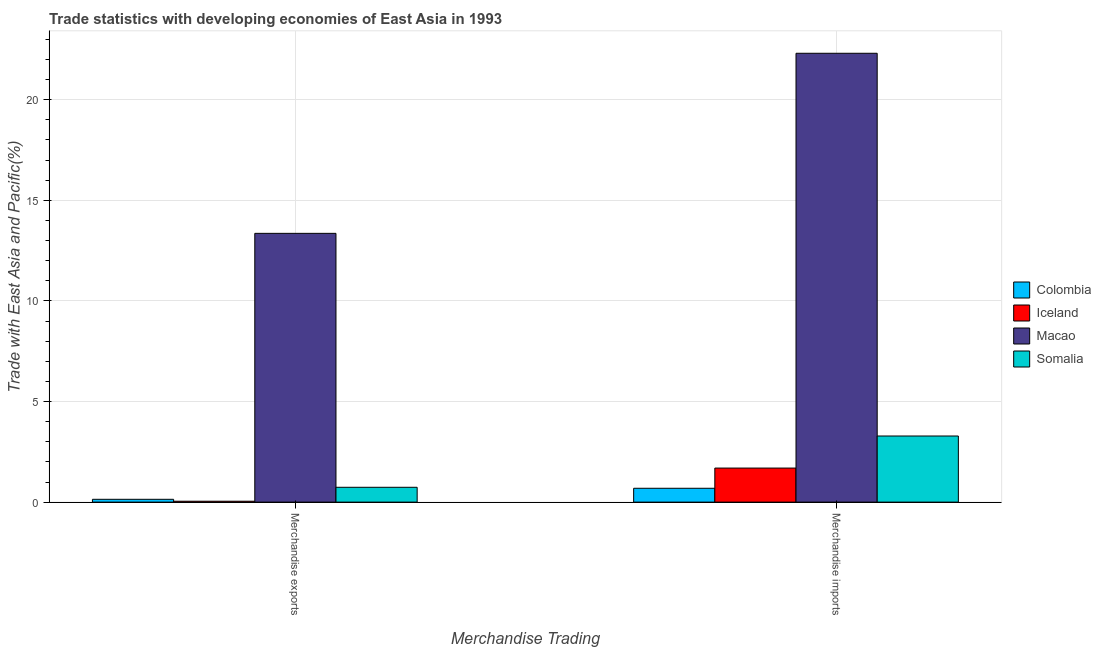Are the number of bars on each tick of the X-axis equal?
Provide a succinct answer. Yes. How many bars are there on the 2nd tick from the left?
Offer a very short reply. 4. What is the label of the 1st group of bars from the left?
Give a very brief answer. Merchandise exports. What is the merchandise imports in Somalia?
Offer a terse response. 3.29. Across all countries, what is the maximum merchandise imports?
Ensure brevity in your answer.  22.31. Across all countries, what is the minimum merchandise exports?
Your response must be concise. 0.04. In which country was the merchandise exports maximum?
Make the answer very short. Macao. What is the total merchandise imports in the graph?
Offer a terse response. 27.97. What is the difference between the merchandise imports in Iceland and that in Somalia?
Your answer should be very brief. -1.59. What is the difference between the merchandise exports in Somalia and the merchandise imports in Iceland?
Provide a succinct answer. -0.96. What is the average merchandise exports per country?
Provide a succinct answer. 3.57. What is the difference between the merchandise exports and merchandise imports in Colombia?
Provide a succinct answer. -0.55. What is the ratio of the merchandise exports in Iceland to that in Macao?
Ensure brevity in your answer.  0. Is the merchandise exports in Iceland less than that in Colombia?
Your answer should be compact. Yes. What does the 3rd bar from the left in Merchandise exports represents?
Give a very brief answer. Macao. What does the 1st bar from the right in Merchandise imports represents?
Your answer should be compact. Somalia. How many countries are there in the graph?
Provide a short and direct response. 4. Are the values on the major ticks of Y-axis written in scientific E-notation?
Keep it short and to the point. No. Does the graph contain any zero values?
Provide a short and direct response. No. Does the graph contain grids?
Your response must be concise. Yes. How many legend labels are there?
Provide a succinct answer. 4. How are the legend labels stacked?
Offer a terse response. Vertical. What is the title of the graph?
Give a very brief answer. Trade statistics with developing economies of East Asia in 1993. What is the label or title of the X-axis?
Make the answer very short. Merchandise Trading. What is the label or title of the Y-axis?
Provide a succinct answer. Trade with East Asia and Pacific(%). What is the Trade with East Asia and Pacific(%) in Colombia in Merchandise exports?
Your response must be concise. 0.14. What is the Trade with East Asia and Pacific(%) of Iceland in Merchandise exports?
Offer a very short reply. 0.04. What is the Trade with East Asia and Pacific(%) of Macao in Merchandise exports?
Give a very brief answer. 13.36. What is the Trade with East Asia and Pacific(%) in Somalia in Merchandise exports?
Provide a succinct answer. 0.74. What is the Trade with East Asia and Pacific(%) in Colombia in Merchandise imports?
Give a very brief answer. 0.69. What is the Trade with East Asia and Pacific(%) of Iceland in Merchandise imports?
Make the answer very short. 1.69. What is the Trade with East Asia and Pacific(%) in Macao in Merchandise imports?
Keep it short and to the point. 22.31. What is the Trade with East Asia and Pacific(%) of Somalia in Merchandise imports?
Give a very brief answer. 3.29. Across all Merchandise Trading, what is the maximum Trade with East Asia and Pacific(%) in Colombia?
Offer a terse response. 0.69. Across all Merchandise Trading, what is the maximum Trade with East Asia and Pacific(%) in Iceland?
Give a very brief answer. 1.69. Across all Merchandise Trading, what is the maximum Trade with East Asia and Pacific(%) of Macao?
Your answer should be compact. 22.31. Across all Merchandise Trading, what is the maximum Trade with East Asia and Pacific(%) in Somalia?
Ensure brevity in your answer.  3.29. Across all Merchandise Trading, what is the minimum Trade with East Asia and Pacific(%) in Colombia?
Offer a terse response. 0.14. Across all Merchandise Trading, what is the minimum Trade with East Asia and Pacific(%) in Iceland?
Offer a terse response. 0.04. Across all Merchandise Trading, what is the minimum Trade with East Asia and Pacific(%) in Macao?
Give a very brief answer. 13.36. Across all Merchandise Trading, what is the minimum Trade with East Asia and Pacific(%) in Somalia?
Keep it short and to the point. 0.74. What is the total Trade with East Asia and Pacific(%) in Colombia in the graph?
Offer a terse response. 0.83. What is the total Trade with East Asia and Pacific(%) of Iceland in the graph?
Offer a terse response. 1.74. What is the total Trade with East Asia and Pacific(%) in Macao in the graph?
Offer a terse response. 35.66. What is the total Trade with East Asia and Pacific(%) in Somalia in the graph?
Ensure brevity in your answer.  4.02. What is the difference between the Trade with East Asia and Pacific(%) in Colombia in Merchandise exports and that in Merchandise imports?
Your answer should be compact. -0.55. What is the difference between the Trade with East Asia and Pacific(%) of Iceland in Merchandise exports and that in Merchandise imports?
Provide a short and direct response. -1.65. What is the difference between the Trade with East Asia and Pacific(%) of Macao in Merchandise exports and that in Merchandise imports?
Make the answer very short. -8.95. What is the difference between the Trade with East Asia and Pacific(%) in Somalia in Merchandise exports and that in Merchandise imports?
Ensure brevity in your answer.  -2.55. What is the difference between the Trade with East Asia and Pacific(%) in Colombia in Merchandise exports and the Trade with East Asia and Pacific(%) in Iceland in Merchandise imports?
Your answer should be compact. -1.55. What is the difference between the Trade with East Asia and Pacific(%) in Colombia in Merchandise exports and the Trade with East Asia and Pacific(%) in Macao in Merchandise imports?
Give a very brief answer. -22.17. What is the difference between the Trade with East Asia and Pacific(%) in Colombia in Merchandise exports and the Trade with East Asia and Pacific(%) in Somalia in Merchandise imports?
Your answer should be compact. -3.15. What is the difference between the Trade with East Asia and Pacific(%) in Iceland in Merchandise exports and the Trade with East Asia and Pacific(%) in Macao in Merchandise imports?
Give a very brief answer. -22.26. What is the difference between the Trade with East Asia and Pacific(%) in Iceland in Merchandise exports and the Trade with East Asia and Pacific(%) in Somalia in Merchandise imports?
Your response must be concise. -3.24. What is the difference between the Trade with East Asia and Pacific(%) in Macao in Merchandise exports and the Trade with East Asia and Pacific(%) in Somalia in Merchandise imports?
Ensure brevity in your answer.  10.07. What is the average Trade with East Asia and Pacific(%) in Colombia per Merchandise Trading?
Provide a short and direct response. 0.41. What is the average Trade with East Asia and Pacific(%) in Iceland per Merchandise Trading?
Give a very brief answer. 0.87. What is the average Trade with East Asia and Pacific(%) in Macao per Merchandise Trading?
Ensure brevity in your answer.  17.83. What is the average Trade with East Asia and Pacific(%) in Somalia per Merchandise Trading?
Provide a short and direct response. 2.01. What is the difference between the Trade with East Asia and Pacific(%) in Colombia and Trade with East Asia and Pacific(%) in Iceland in Merchandise exports?
Offer a very short reply. 0.1. What is the difference between the Trade with East Asia and Pacific(%) of Colombia and Trade with East Asia and Pacific(%) of Macao in Merchandise exports?
Offer a terse response. -13.22. What is the difference between the Trade with East Asia and Pacific(%) of Colombia and Trade with East Asia and Pacific(%) of Somalia in Merchandise exports?
Provide a short and direct response. -0.6. What is the difference between the Trade with East Asia and Pacific(%) in Iceland and Trade with East Asia and Pacific(%) in Macao in Merchandise exports?
Offer a terse response. -13.31. What is the difference between the Trade with East Asia and Pacific(%) of Iceland and Trade with East Asia and Pacific(%) of Somalia in Merchandise exports?
Give a very brief answer. -0.69. What is the difference between the Trade with East Asia and Pacific(%) in Macao and Trade with East Asia and Pacific(%) in Somalia in Merchandise exports?
Keep it short and to the point. 12.62. What is the difference between the Trade with East Asia and Pacific(%) of Colombia and Trade with East Asia and Pacific(%) of Iceland in Merchandise imports?
Provide a short and direct response. -1. What is the difference between the Trade with East Asia and Pacific(%) of Colombia and Trade with East Asia and Pacific(%) of Macao in Merchandise imports?
Offer a terse response. -21.62. What is the difference between the Trade with East Asia and Pacific(%) of Colombia and Trade with East Asia and Pacific(%) of Somalia in Merchandise imports?
Give a very brief answer. -2.6. What is the difference between the Trade with East Asia and Pacific(%) of Iceland and Trade with East Asia and Pacific(%) of Macao in Merchandise imports?
Ensure brevity in your answer.  -20.61. What is the difference between the Trade with East Asia and Pacific(%) of Iceland and Trade with East Asia and Pacific(%) of Somalia in Merchandise imports?
Your answer should be very brief. -1.59. What is the difference between the Trade with East Asia and Pacific(%) in Macao and Trade with East Asia and Pacific(%) in Somalia in Merchandise imports?
Your answer should be compact. 19.02. What is the ratio of the Trade with East Asia and Pacific(%) in Colombia in Merchandise exports to that in Merchandise imports?
Provide a succinct answer. 0.2. What is the ratio of the Trade with East Asia and Pacific(%) in Iceland in Merchandise exports to that in Merchandise imports?
Offer a terse response. 0.03. What is the ratio of the Trade with East Asia and Pacific(%) of Macao in Merchandise exports to that in Merchandise imports?
Keep it short and to the point. 0.6. What is the ratio of the Trade with East Asia and Pacific(%) of Somalia in Merchandise exports to that in Merchandise imports?
Your response must be concise. 0.22. What is the difference between the highest and the second highest Trade with East Asia and Pacific(%) of Colombia?
Give a very brief answer. 0.55. What is the difference between the highest and the second highest Trade with East Asia and Pacific(%) of Iceland?
Provide a short and direct response. 1.65. What is the difference between the highest and the second highest Trade with East Asia and Pacific(%) in Macao?
Make the answer very short. 8.95. What is the difference between the highest and the second highest Trade with East Asia and Pacific(%) in Somalia?
Keep it short and to the point. 2.55. What is the difference between the highest and the lowest Trade with East Asia and Pacific(%) of Colombia?
Make the answer very short. 0.55. What is the difference between the highest and the lowest Trade with East Asia and Pacific(%) in Iceland?
Give a very brief answer. 1.65. What is the difference between the highest and the lowest Trade with East Asia and Pacific(%) of Macao?
Your answer should be very brief. 8.95. What is the difference between the highest and the lowest Trade with East Asia and Pacific(%) of Somalia?
Ensure brevity in your answer.  2.55. 